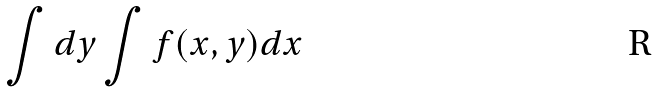Convert formula to latex. <formula><loc_0><loc_0><loc_500><loc_500>\int d y \int f ( x , y ) d x</formula> 